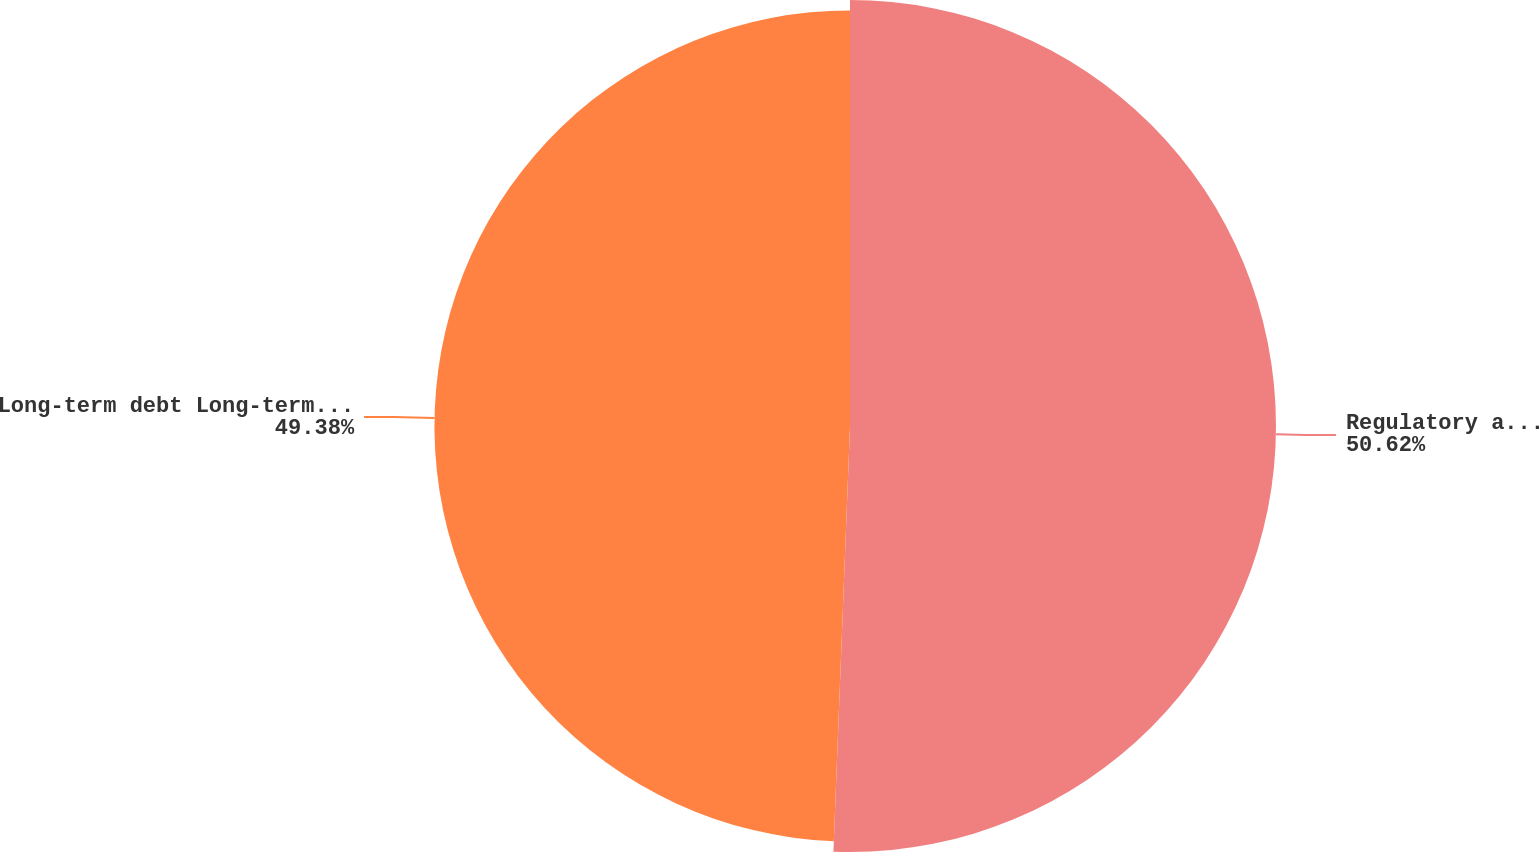Convert chart. <chart><loc_0><loc_0><loc_500><loc_500><pie_chart><fcel>Regulatory and other long-term<fcel>Long-term debt Long-term debt<nl><fcel>50.62%<fcel>49.38%<nl></chart> 